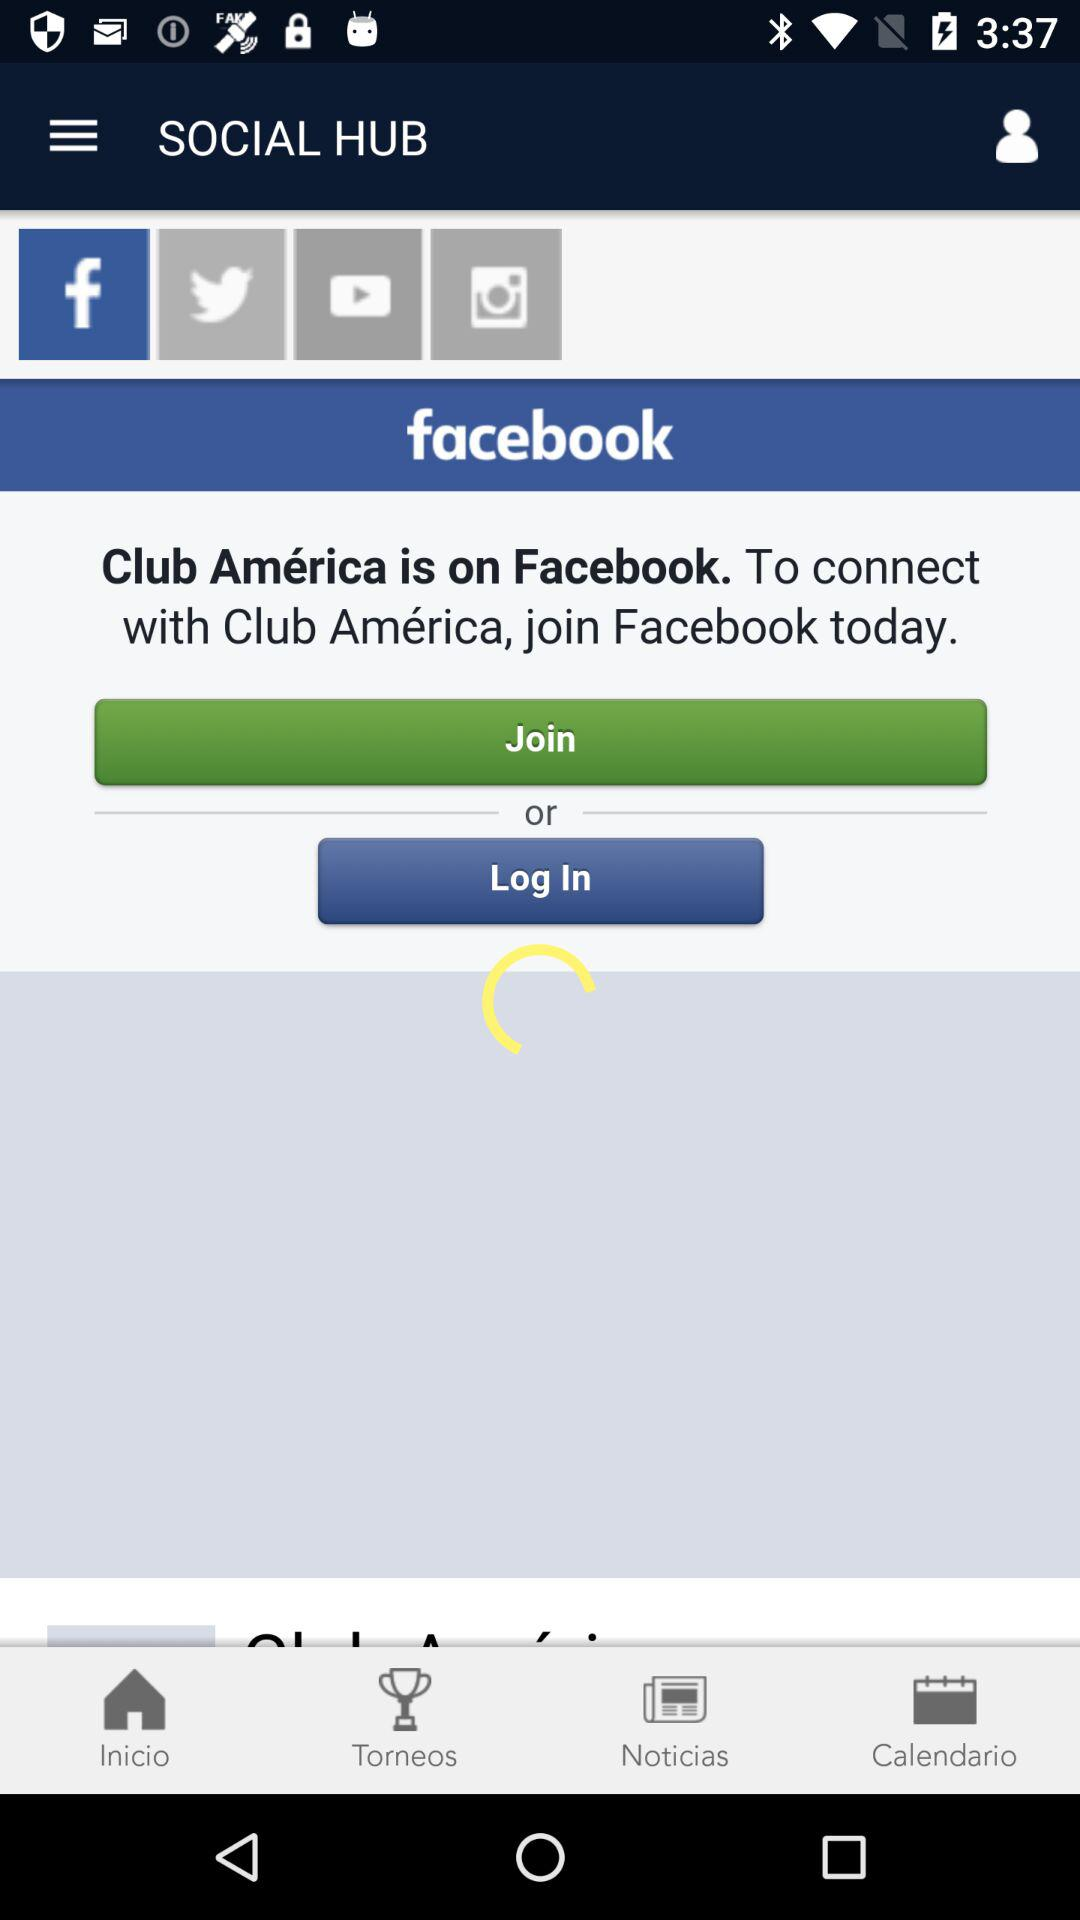What is the app name? The app names are "SOCIAL HUB" and "facebook". 